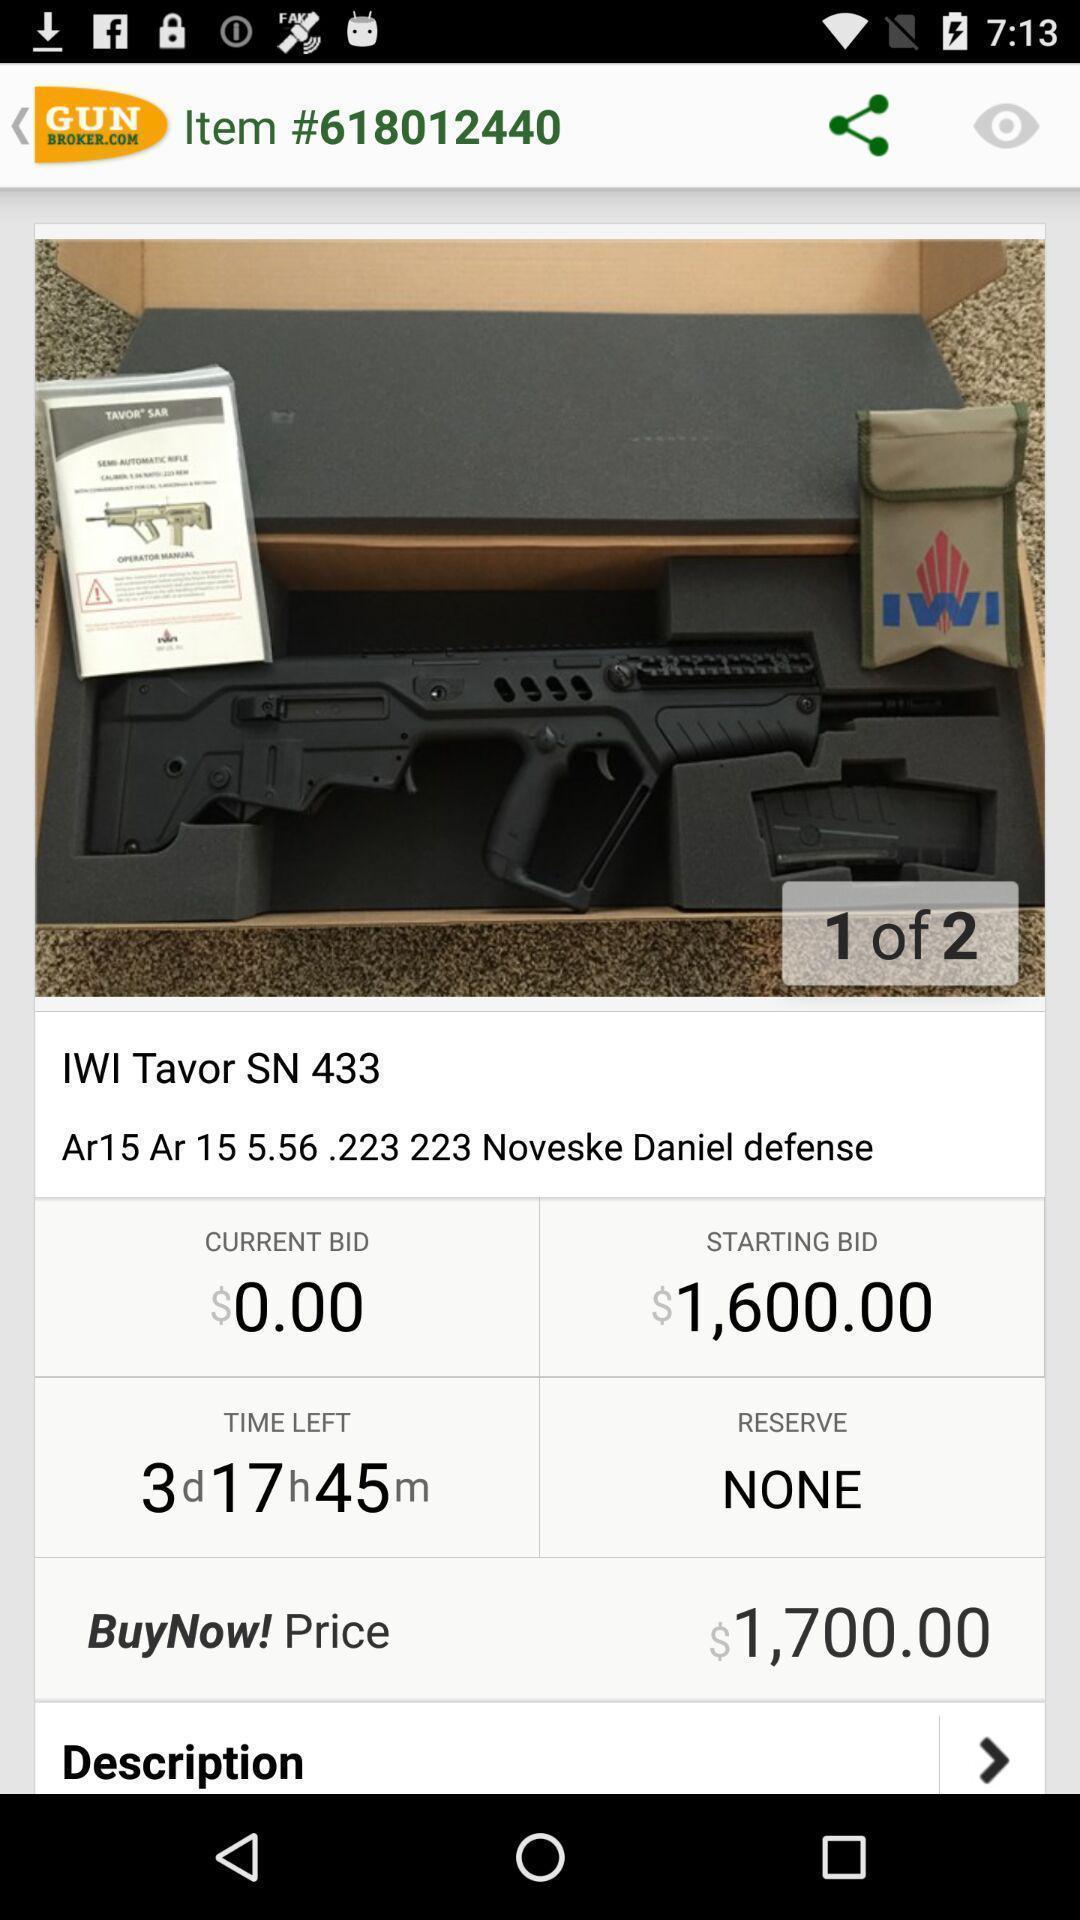What can you discern from this picture? Screen showing the details of weapon. 